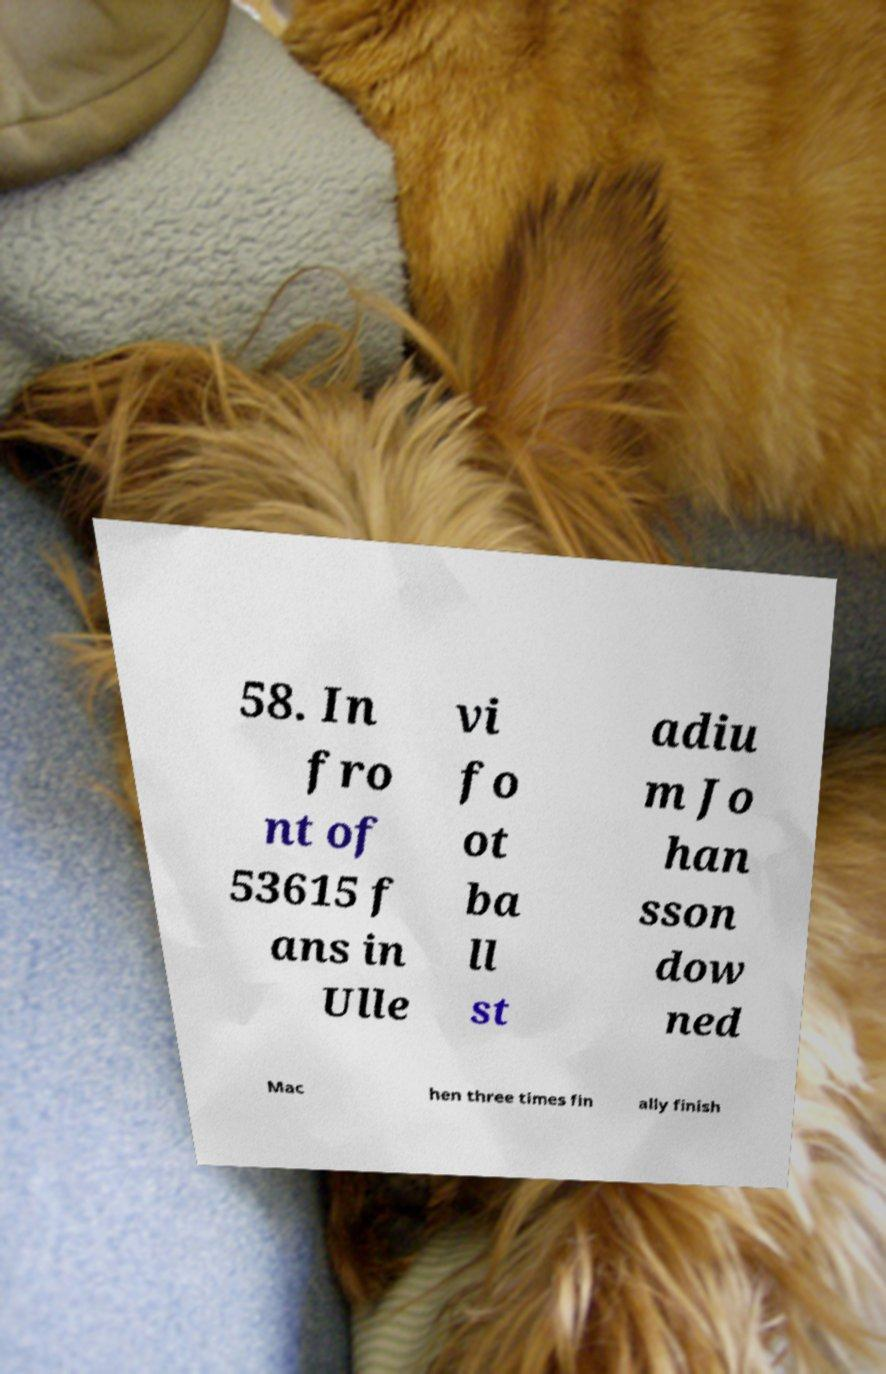Please read and relay the text visible in this image. What does it say? 58. In fro nt of 53615 f ans in Ulle vi fo ot ba ll st adiu m Jo han sson dow ned Mac hen three times fin ally finish 